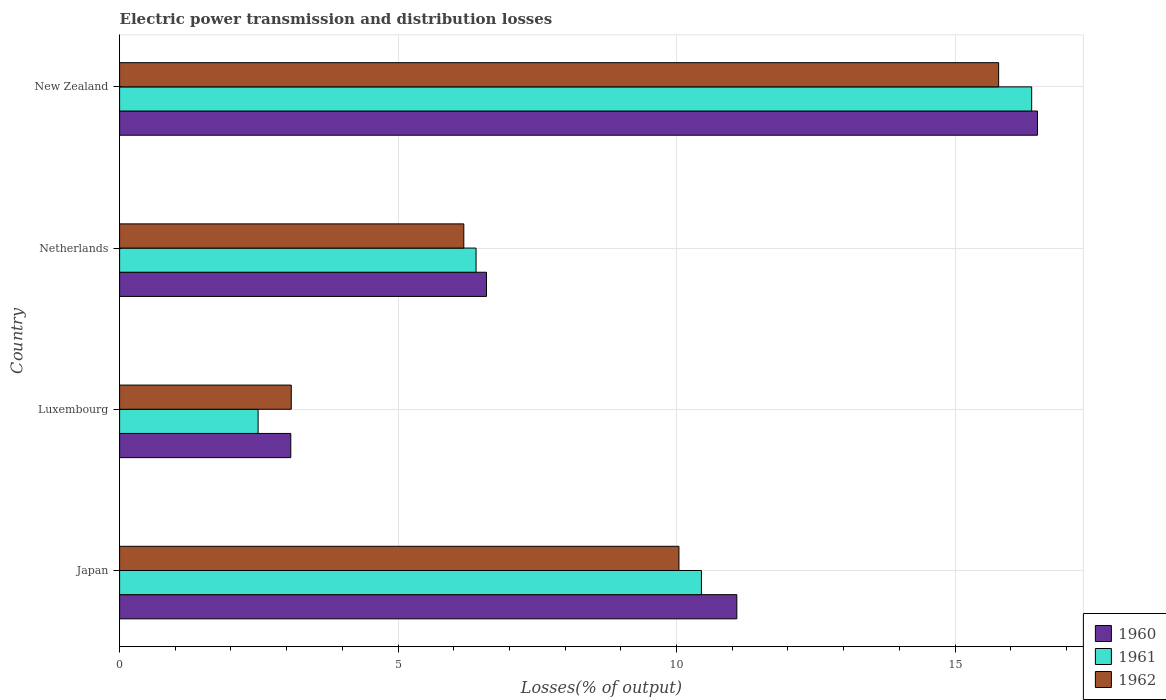How many groups of bars are there?
Provide a succinct answer. 4. Are the number of bars on each tick of the Y-axis equal?
Ensure brevity in your answer.  Yes. How many bars are there on the 3rd tick from the top?
Provide a short and direct response. 3. How many bars are there on the 4th tick from the bottom?
Ensure brevity in your answer.  3. What is the label of the 2nd group of bars from the top?
Offer a very short reply. Netherlands. What is the electric power transmission and distribution losses in 1960 in New Zealand?
Make the answer very short. 16.48. Across all countries, what is the maximum electric power transmission and distribution losses in 1960?
Provide a short and direct response. 16.48. Across all countries, what is the minimum electric power transmission and distribution losses in 1962?
Your answer should be compact. 3.08. In which country was the electric power transmission and distribution losses in 1962 maximum?
Offer a terse response. New Zealand. In which country was the electric power transmission and distribution losses in 1961 minimum?
Keep it short and to the point. Luxembourg. What is the total electric power transmission and distribution losses in 1960 in the graph?
Your response must be concise. 37.22. What is the difference between the electric power transmission and distribution losses in 1961 in Netherlands and that in New Zealand?
Give a very brief answer. -9.98. What is the difference between the electric power transmission and distribution losses in 1960 in New Zealand and the electric power transmission and distribution losses in 1962 in Netherlands?
Offer a terse response. 10.3. What is the average electric power transmission and distribution losses in 1961 per country?
Provide a succinct answer. 8.93. What is the difference between the electric power transmission and distribution losses in 1960 and electric power transmission and distribution losses in 1962 in Luxembourg?
Your answer should be very brief. -0.01. In how many countries, is the electric power transmission and distribution losses in 1962 greater than 4 %?
Your response must be concise. 3. What is the ratio of the electric power transmission and distribution losses in 1960 in Netherlands to that in New Zealand?
Ensure brevity in your answer.  0.4. Is the electric power transmission and distribution losses in 1960 in Japan less than that in Netherlands?
Keep it short and to the point. No. What is the difference between the highest and the second highest electric power transmission and distribution losses in 1962?
Make the answer very short. 5.74. What is the difference between the highest and the lowest electric power transmission and distribution losses in 1962?
Provide a succinct answer. 12.7. In how many countries, is the electric power transmission and distribution losses in 1960 greater than the average electric power transmission and distribution losses in 1960 taken over all countries?
Keep it short and to the point. 2. Is the sum of the electric power transmission and distribution losses in 1961 in Luxembourg and Netherlands greater than the maximum electric power transmission and distribution losses in 1960 across all countries?
Make the answer very short. No. What does the 3rd bar from the top in New Zealand represents?
Keep it short and to the point. 1960. What does the 2nd bar from the bottom in New Zealand represents?
Offer a terse response. 1961. Is it the case that in every country, the sum of the electric power transmission and distribution losses in 1961 and electric power transmission and distribution losses in 1962 is greater than the electric power transmission and distribution losses in 1960?
Provide a succinct answer. Yes. What is the difference between two consecutive major ticks on the X-axis?
Your answer should be compact. 5. Does the graph contain any zero values?
Ensure brevity in your answer.  No. Does the graph contain grids?
Provide a short and direct response. Yes. Where does the legend appear in the graph?
Give a very brief answer. Bottom right. What is the title of the graph?
Give a very brief answer. Electric power transmission and distribution losses. What is the label or title of the X-axis?
Provide a succinct answer. Losses(% of output). What is the label or title of the Y-axis?
Your answer should be very brief. Country. What is the Losses(% of output) of 1960 in Japan?
Offer a terse response. 11.08. What is the Losses(% of output) of 1961 in Japan?
Ensure brevity in your answer.  10.45. What is the Losses(% of output) of 1962 in Japan?
Provide a succinct answer. 10.04. What is the Losses(% of output) in 1960 in Luxembourg?
Your response must be concise. 3.07. What is the Losses(% of output) in 1961 in Luxembourg?
Your response must be concise. 2.49. What is the Losses(% of output) in 1962 in Luxembourg?
Give a very brief answer. 3.08. What is the Losses(% of output) of 1960 in Netherlands?
Offer a very short reply. 6.59. What is the Losses(% of output) of 1961 in Netherlands?
Your response must be concise. 6.4. What is the Losses(% of output) in 1962 in Netherlands?
Your answer should be very brief. 6.18. What is the Losses(% of output) of 1960 in New Zealand?
Your response must be concise. 16.48. What is the Losses(% of output) in 1961 in New Zealand?
Offer a terse response. 16.38. What is the Losses(% of output) in 1962 in New Zealand?
Your response must be concise. 15.78. Across all countries, what is the maximum Losses(% of output) of 1960?
Give a very brief answer. 16.48. Across all countries, what is the maximum Losses(% of output) in 1961?
Provide a short and direct response. 16.38. Across all countries, what is the maximum Losses(% of output) in 1962?
Provide a short and direct response. 15.78. Across all countries, what is the minimum Losses(% of output) of 1960?
Your response must be concise. 3.07. Across all countries, what is the minimum Losses(% of output) of 1961?
Give a very brief answer. 2.49. Across all countries, what is the minimum Losses(% of output) of 1962?
Keep it short and to the point. 3.08. What is the total Losses(% of output) in 1960 in the graph?
Provide a succinct answer. 37.22. What is the total Losses(% of output) of 1961 in the graph?
Ensure brevity in your answer.  35.71. What is the total Losses(% of output) of 1962 in the graph?
Your answer should be very brief. 35.09. What is the difference between the Losses(% of output) in 1960 in Japan and that in Luxembourg?
Make the answer very short. 8.01. What is the difference between the Losses(% of output) of 1961 in Japan and that in Luxembourg?
Ensure brevity in your answer.  7.96. What is the difference between the Losses(% of output) of 1962 in Japan and that in Luxembourg?
Provide a short and direct response. 6.96. What is the difference between the Losses(% of output) in 1960 in Japan and that in Netherlands?
Provide a succinct answer. 4.49. What is the difference between the Losses(% of output) of 1961 in Japan and that in Netherlands?
Keep it short and to the point. 4.05. What is the difference between the Losses(% of output) of 1962 in Japan and that in Netherlands?
Give a very brief answer. 3.86. What is the difference between the Losses(% of output) of 1960 in Japan and that in New Zealand?
Provide a short and direct response. -5.4. What is the difference between the Losses(% of output) of 1961 in Japan and that in New Zealand?
Your response must be concise. -5.93. What is the difference between the Losses(% of output) in 1962 in Japan and that in New Zealand?
Offer a terse response. -5.74. What is the difference between the Losses(% of output) of 1960 in Luxembourg and that in Netherlands?
Keep it short and to the point. -3.51. What is the difference between the Losses(% of output) in 1961 in Luxembourg and that in Netherlands?
Keep it short and to the point. -3.91. What is the difference between the Losses(% of output) of 1962 in Luxembourg and that in Netherlands?
Your answer should be very brief. -3.1. What is the difference between the Losses(% of output) of 1960 in Luxembourg and that in New Zealand?
Ensure brevity in your answer.  -13.41. What is the difference between the Losses(% of output) in 1961 in Luxembourg and that in New Zealand?
Make the answer very short. -13.89. What is the difference between the Losses(% of output) of 1962 in Luxembourg and that in New Zealand?
Your answer should be very brief. -12.7. What is the difference between the Losses(% of output) in 1960 in Netherlands and that in New Zealand?
Offer a very short reply. -9.89. What is the difference between the Losses(% of output) of 1961 in Netherlands and that in New Zealand?
Ensure brevity in your answer.  -9.98. What is the difference between the Losses(% of output) in 1962 in Netherlands and that in New Zealand?
Provide a succinct answer. -9.6. What is the difference between the Losses(% of output) in 1960 in Japan and the Losses(% of output) in 1961 in Luxembourg?
Your response must be concise. 8.6. What is the difference between the Losses(% of output) of 1960 in Japan and the Losses(% of output) of 1962 in Luxembourg?
Offer a very short reply. 8. What is the difference between the Losses(% of output) in 1961 in Japan and the Losses(% of output) in 1962 in Luxembourg?
Provide a succinct answer. 7.36. What is the difference between the Losses(% of output) in 1960 in Japan and the Losses(% of output) in 1961 in Netherlands?
Offer a very short reply. 4.68. What is the difference between the Losses(% of output) in 1960 in Japan and the Losses(% of output) in 1962 in Netherlands?
Offer a terse response. 4.9. What is the difference between the Losses(% of output) in 1961 in Japan and the Losses(% of output) in 1962 in Netherlands?
Provide a short and direct response. 4.27. What is the difference between the Losses(% of output) in 1960 in Japan and the Losses(% of output) in 1961 in New Zealand?
Your response must be concise. -5.29. What is the difference between the Losses(% of output) of 1960 in Japan and the Losses(% of output) of 1962 in New Zealand?
Offer a terse response. -4.7. What is the difference between the Losses(% of output) in 1961 in Japan and the Losses(% of output) in 1962 in New Zealand?
Offer a terse response. -5.34. What is the difference between the Losses(% of output) of 1960 in Luxembourg and the Losses(% of output) of 1961 in Netherlands?
Ensure brevity in your answer.  -3.33. What is the difference between the Losses(% of output) of 1960 in Luxembourg and the Losses(% of output) of 1962 in Netherlands?
Your answer should be compact. -3.11. What is the difference between the Losses(% of output) of 1961 in Luxembourg and the Losses(% of output) of 1962 in Netherlands?
Provide a succinct answer. -3.69. What is the difference between the Losses(% of output) of 1960 in Luxembourg and the Losses(% of output) of 1961 in New Zealand?
Provide a short and direct response. -13.3. What is the difference between the Losses(% of output) in 1960 in Luxembourg and the Losses(% of output) in 1962 in New Zealand?
Make the answer very short. -12.71. What is the difference between the Losses(% of output) of 1961 in Luxembourg and the Losses(% of output) of 1962 in New Zealand?
Offer a very short reply. -13.3. What is the difference between the Losses(% of output) in 1960 in Netherlands and the Losses(% of output) in 1961 in New Zealand?
Your answer should be compact. -9.79. What is the difference between the Losses(% of output) of 1960 in Netherlands and the Losses(% of output) of 1962 in New Zealand?
Your response must be concise. -9.2. What is the difference between the Losses(% of output) of 1961 in Netherlands and the Losses(% of output) of 1962 in New Zealand?
Give a very brief answer. -9.38. What is the average Losses(% of output) in 1960 per country?
Give a very brief answer. 9.31. What is the average Losses(% of output) in 1961 per country?
Give a very brief answer. 8.93. What is the average Losses(% of output) of 1962 per country?
Provide a short and direct response. 8.77. What is the difference between the Losses(% of output) of 1960 and Losses(% of output) of 1961 in Japan?
Your answer should be very brief. 0.64. What is the difference between the Losses(% of output) of 1960 and Losses(% of output) of 1962 in Japan?
Keep it short and to the point. 1.04. What is the difference between the Losses(% of output) in 1961 and Losses(% of output) in 1962 in Japan?
Make the answer very short. 0.4. What is the difference between the Losses(% of output) of 1960 and Losses(% of output) of 1961 in Luxembourg?
Offer a very short reply. 0.59. What is the difference between the Losses(% of output) of 1960 and Losses(% of output) of 1962 in Luxembourg?
Offer a very short reply. -0.01. What is the difference between the Losses(% of output) of 1961 and Losses(% of output) of 1962 in Luxembourg?
Make the answer very short. -0.6. What is the difference between the Losses(% of output) in 1960 and Losses(% of output) in 1961 in Netherlands?
Your answer should be compact. 0.19. What is the difference between the Losses(% of output) of 1960 and Losses(% of output) of 1962 in Netherlands?
Offer a very short reply. 0.41. What is the difference between the Losses(% of output) in 1961 and Losses(% of output) in 1962 in Netherlands?
Your answer should be compact. 0.22. What is the difference between the Losses(% of output) in 1960 and Losses(% of output) in 1961 in New Zealand?
Ensure brevity in your answer.  0.1. What is the difference between the Losses(% of output) of 1960 and Losses(% of output) of 1962 in New Zealand?
Provide a succinct answer. 0.7. What is the difference between the Losses(% of output) in 1961 and Losses(% of output) in 1962 in New Zealand?
Provide a short and direct response. 0.59. What is the ratio of the Losses(% of output) of 1960 in Japan to that in Luxembourg?
Your answer should be very brief. 3.61. What is the ratio of the Losses(% of output) in 1961 in Japan to that in Luxembourg?
Keep it short and to the point. 4.2. What is the ratio of the Losses(% of output) in 1962 in Japan to that in Luxembourg?
Make the answer very short. 3.26. What is the ratio of the Losses(% of output) in 1960 in Japan to that in Netherlands?
Provide a succinct answer. 1.68. What is the ratio of the Losses(% of output) of 1961 in Japan to that in Netherlands?
Your answer should be compact. 1.63. What is the ratio of the Losses(% of output) in 1962 in Japan to that in Netherlands?
Give a very brief answer. 1.62. What is the ratio of the Losses(% of output) in 1960 in Japan to that in New Zealand?
Give a very brief answer. 0.67. What is the ratio of the Losses(% of output) in 1961 in Japan to that in New Zealand?
Offer a terse response. 0.64. What is the ratio of the Losses(% of output) in 1962 in Japan to that in New Zealand?
Offer a very short reply. 0.64. What is the ratio of the Losses(% of output) in 1960 in Luxembourg to that in Netherlands?
Make the answer very short. 0.47. What is the ratio of the Losses(% of output) in 1961 in Luxembourg to that in Netherlands?
Offer a terse response. 0.39. What is the ratio of the Losses(% of output) in 1962 in Luxembourg to that in Netherlands?
Your answer should be very brief. 0.5. What is the ratio of the Losses(% of output) in 1960 in Luxembourg to that in New Zealand?
Your answer should be very brief. 0.19. What is the ratio of the Losses(% of output) in 1961 in Luxembourg to that in New Zealand?
Keep it short and to the point. 0.15. What is the ratio of the Losses(% of output) of 1962 in Luxembourg to that in New Zealand?
Make the answer very short. 0.2. What is the ratio of the Losses(% of output) in 1960 in Netherlands to that in New Zealand?
Your response must be concise. 0.4. What is the ratio of the Losses(% of output) of 1961 in Netherlands to that in New Zealand?
Offer a terse response. 0.39. What is the ratio of the Losses(% of output) in 1962 in Netherlands to that in New Zealand?
Ensure brevity in your answer.  0.39. What is the difference between the highest and the second highest Losses(% of output) of 1960?
Your answer should be very brief. 5.4. What is the difference between the highest and the second highest Losses(% of output) of 1961?
Give a very brief answer. 5.93. What is the difference between the highest and the second highest Losses(% of output) in 1962?
Keep it short and to the point. 5.74. What is the difference between the highest and the lowest Losses(% of output) of 1960?
Your answer should be compact. 13.41. What is the difference between the highest and the lowest Losses(% of output) of 1961?
Offer a terse response. 13.89. What is the difference between the highest and the lowest Losses(% of output) in 1962?
Offer a very short reply. 12.7. 